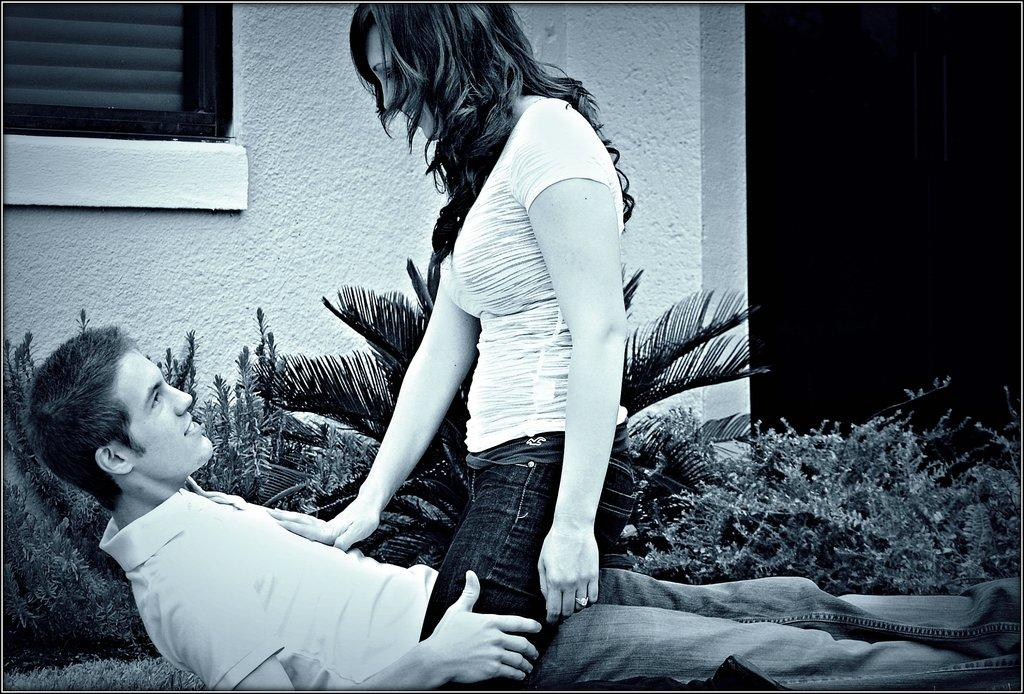What is the man in the image doing? The man is lying down in the image. What is the man wearing in the image? The man is wearing a t-shirt. What is the girl in the image doing? The girl is standing in the image. What is the girl wearing in the image? The girl is wearing a t-shirt. What type of vegetation can be seen in the image? There are plants visible in the image. What is the background of the image made of? There is a wall in the image. What type of bell can be heard ringing in the image? There is no bell present or ringing in the image. Can you provide an example of the girl's behavior in the image? The image does not show any specific behavior of the girl, only her standing position. 